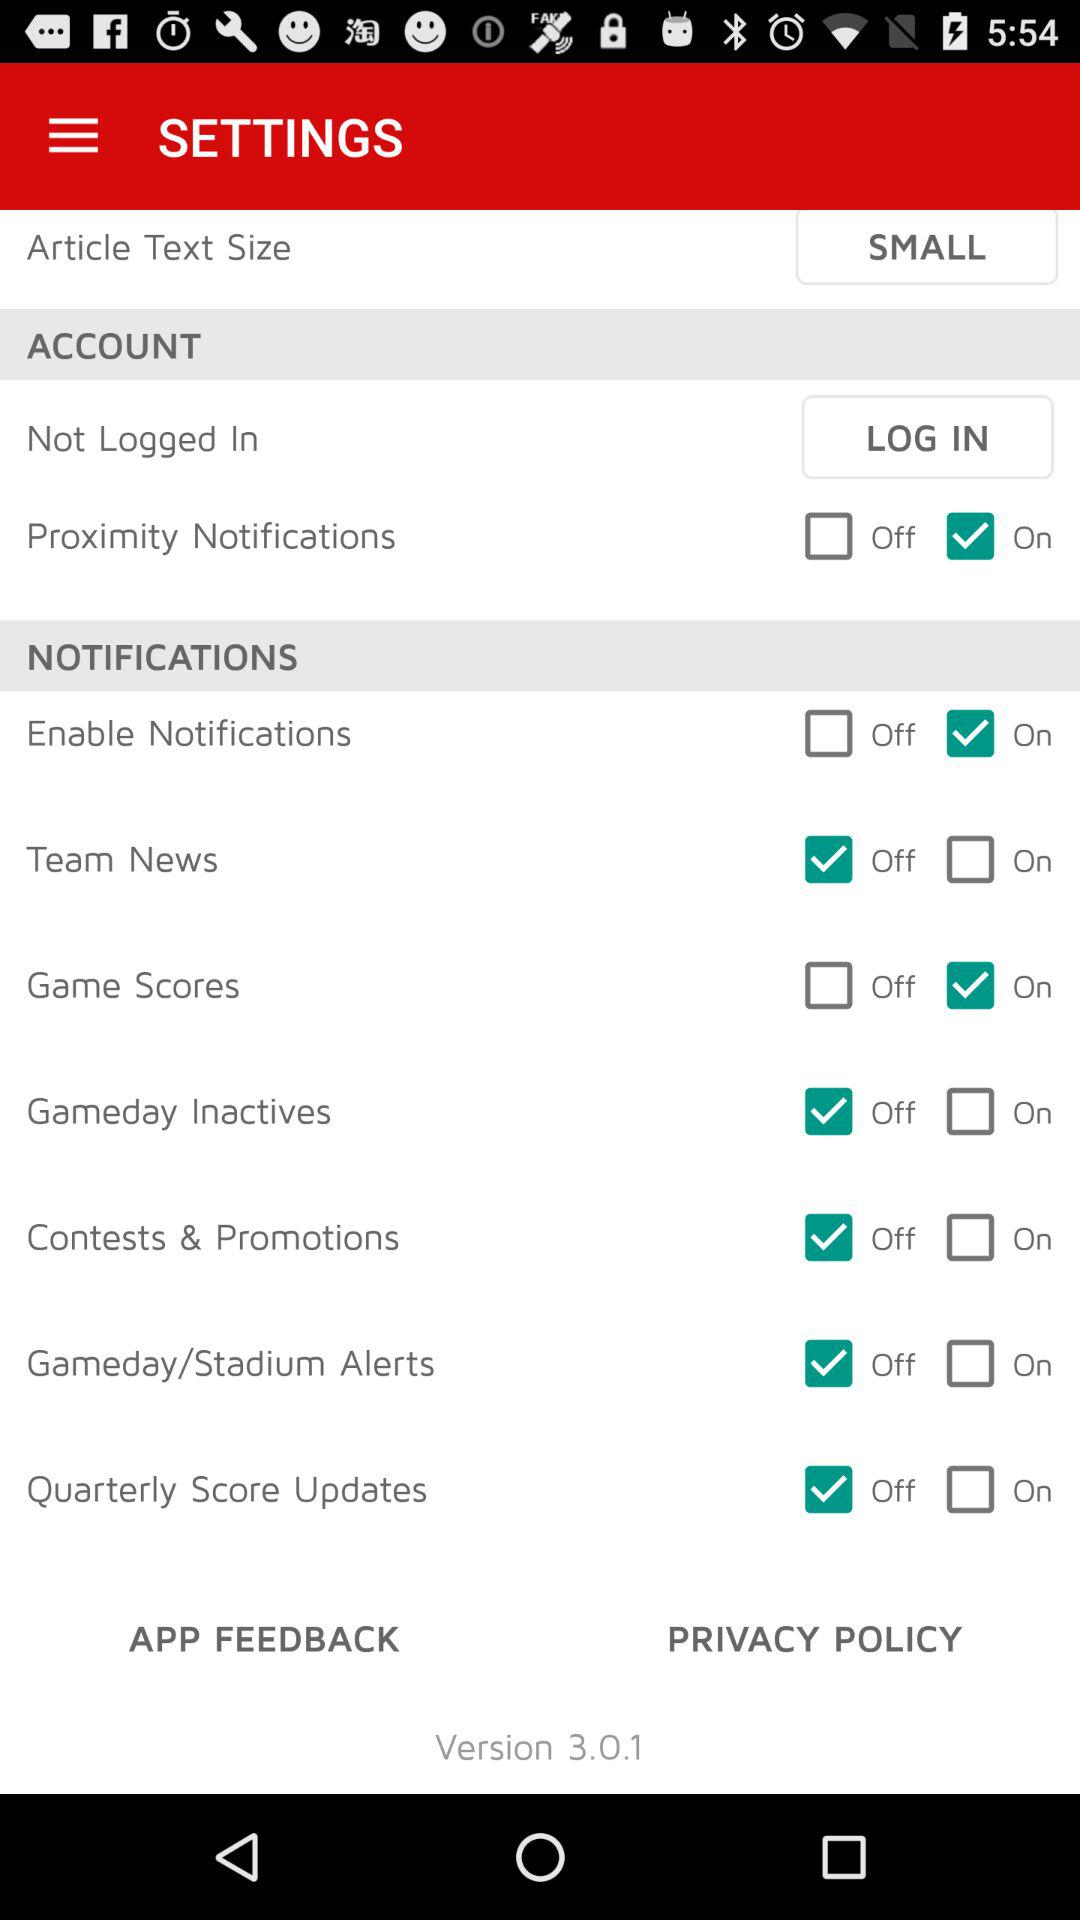What is the status of "Gameday Inactives"? The status of "Gameday Inactives" is "off". 